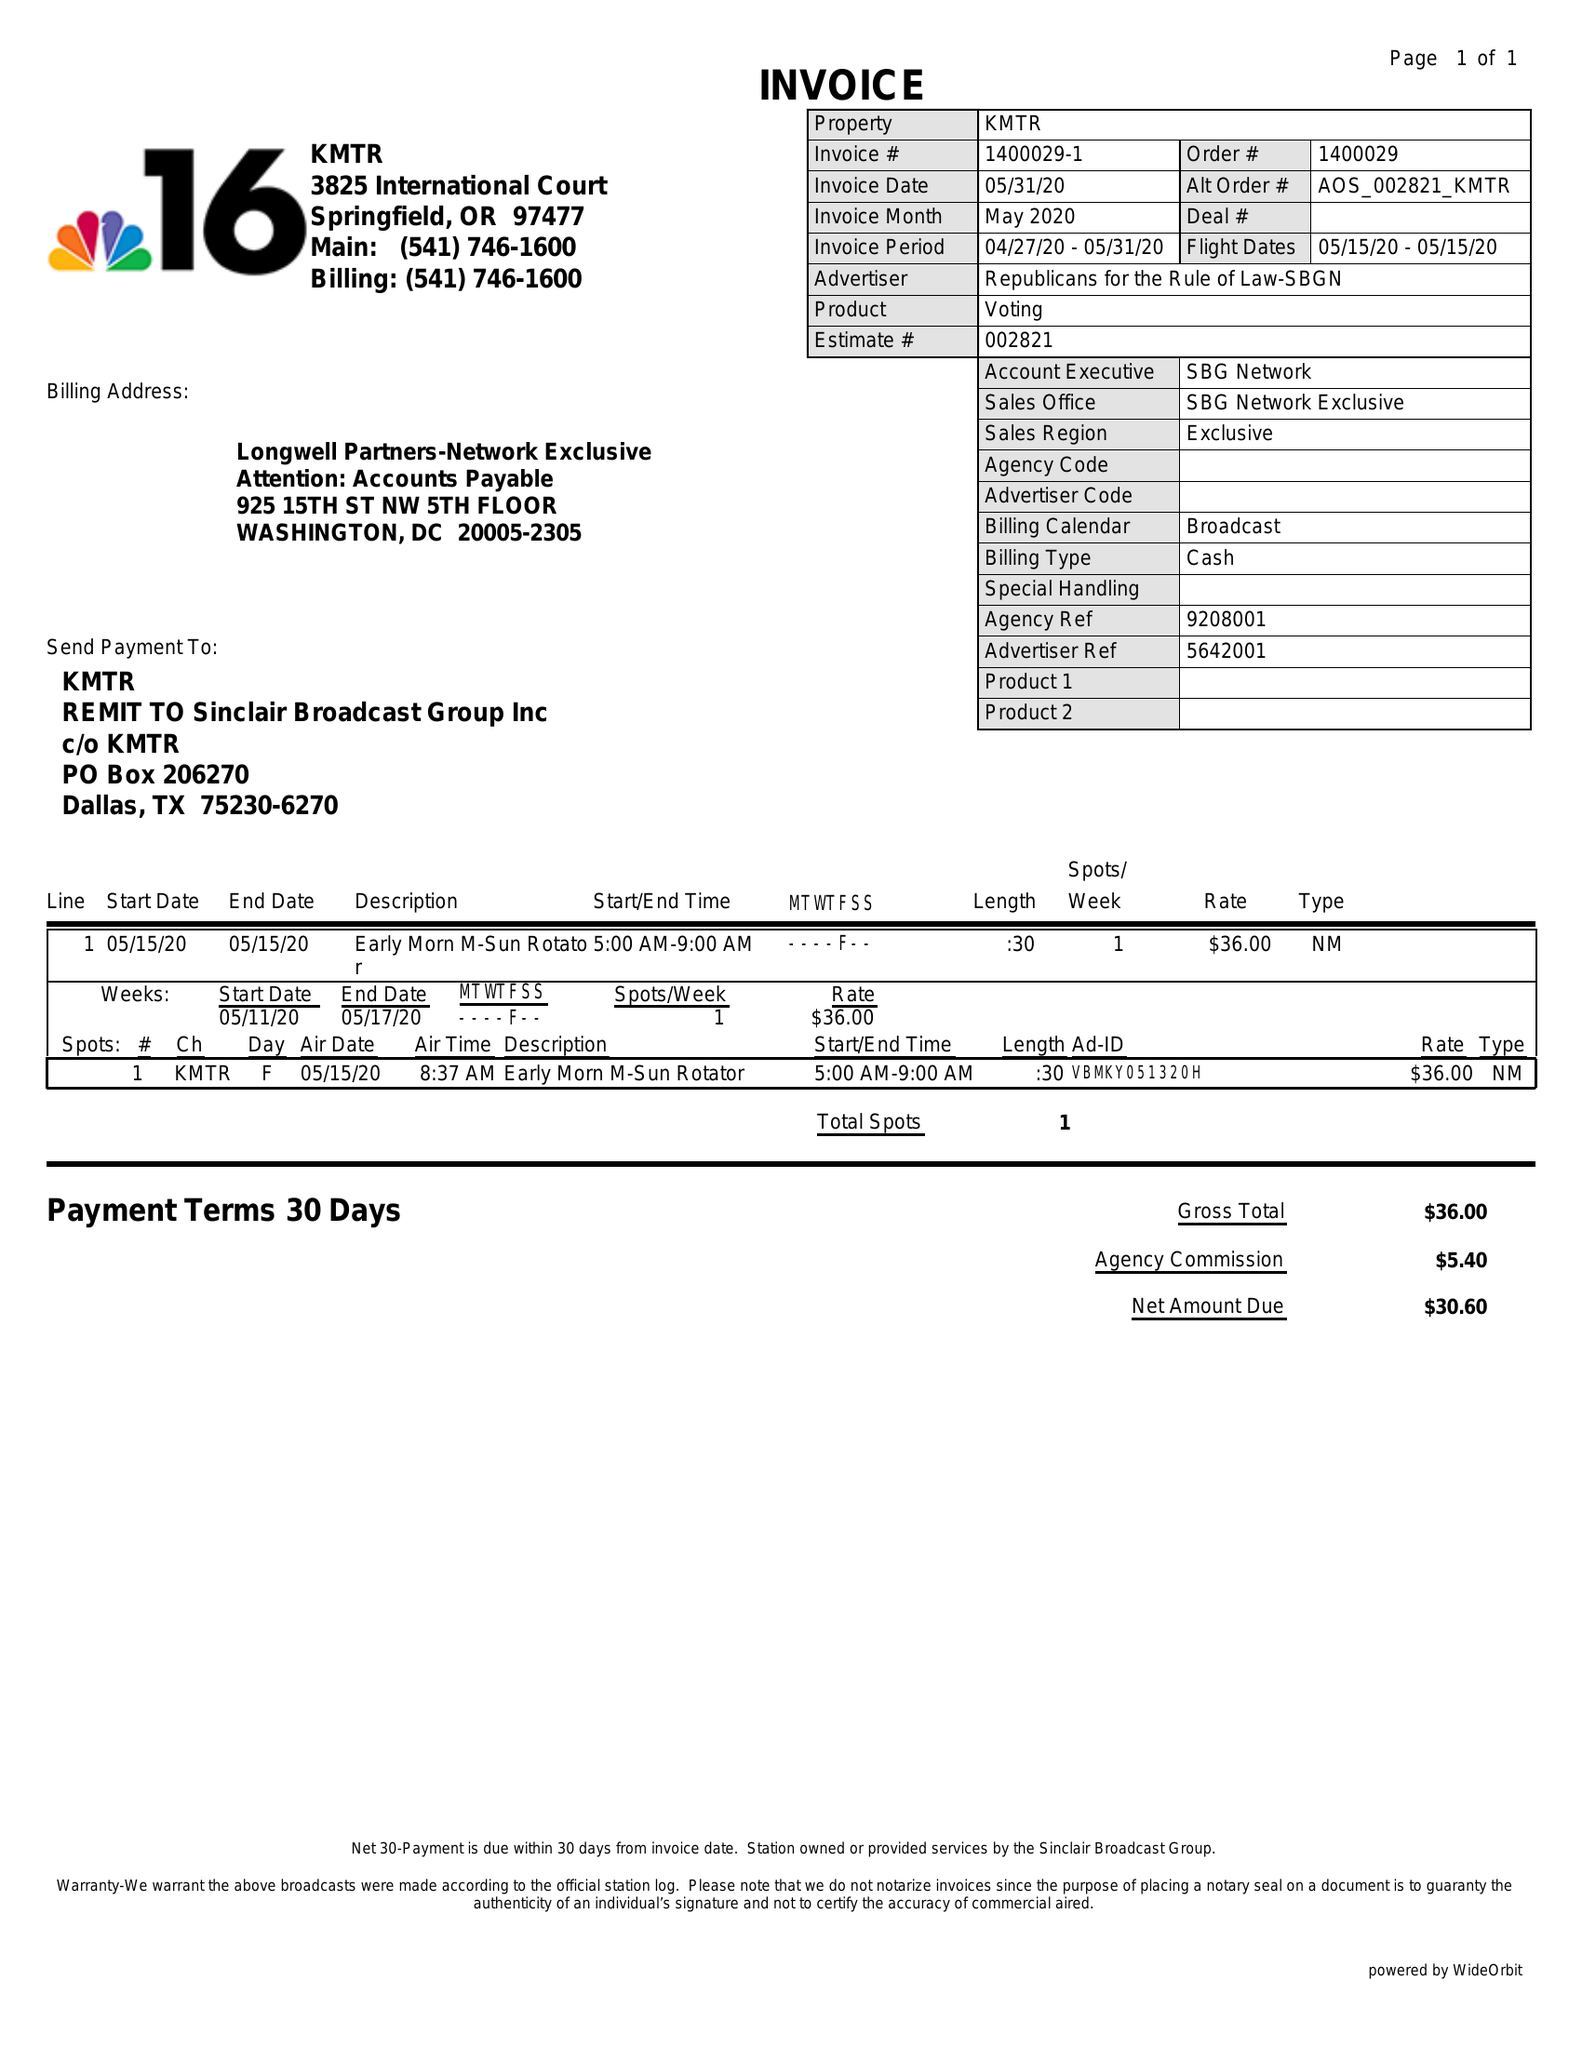What is the value for the gross_amount?
Answer the question using a single word or phrase. 36.00 